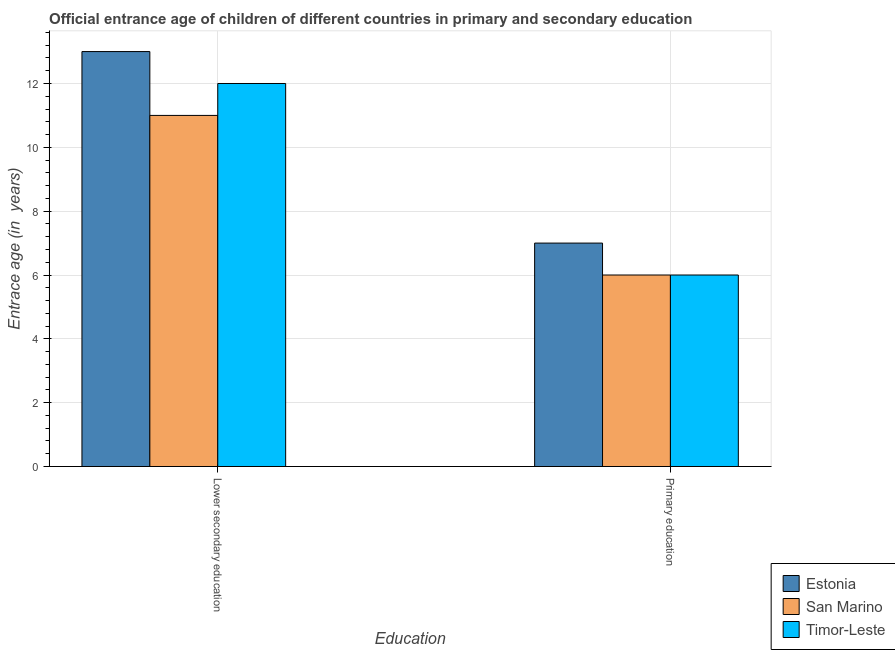How many groups of bars are there?
Make the answer very short. 2. How many bars are there on the 1st tick from the right?
Provide a short and direct response. 3. What is the label of the 2nd group of bars from the left?
Keep it short and to the point. Primary education. What is the entrance age of chiildren in primary education in Timor-Leste?
Provide a short and direct response. 6. Across all countries, what is the maximum entrance age of children in lower secondary education?
Ensure brevity in your answer.  13. Across all countries, what is the minimum entrance age of chiildren in primary education?
Your answer should be very brief. 6. In which country was the entrance age of children in lower secondary education maximum?
Your response must be concise. Estonia. In which country was the entrance age of chiildren in primary education minimum?
Give a very brief answer. San Marino. What is the total entrance age of chiildren in primary education in the graph?
Ensure brevity in your answer.  19. What is the difference between the entrance age of children in lower secondary education in Estonia and that in San Marino?
Your answer should be compact. 2. What is the difference between the entrance age of children in lower secondary education in Estonia and the entrance age of chiildren in primary education in Timor-Leste?
Offer a terse response. 7. What is the average entrance age of chiildren in primary education per country?
Your answer should be compact. 6.33. What is the difference between the entrance age of chiildren in primary education and entrance age of children in lower secondary education in Timor-Leste?
Your answer should be compact. -6. In how many countries, is the entrance age of chiildren in primary education greater than 6.8 years?
Make the answer very short. 1. What is the ratio of the entrance age of chiildren in primary education in San Marino to that in Timor-Leste?
Your answer should be very brief. 1. What does the 1st bar from the left in Lower secondary education represents?
Your response must be concise. Estonia. What does the 3rd bar from the right in Primary education represents?
Ensure brevity in your answer.  Estonia. Are all the bars in the graph horizontal?
Make the answer very short. No. Does the graph contain any zero values?
Ensure brevity in your answer.  No. Where does the legend appear in the graph?
Your answer should be compact. Bottom right. How many legend labels are there?
Make the answer very short. 3. What is the title of the graph?
Your answer should be compact. Official entrance age of children of different countries in primary and secondary education. Does "Nepal" appear as one of the legend labels in the graph?
Give a very brief answer. No. What is the label or title of the X-axis?
Provide a succinct answer. Education. What is the label or title of the Y-axis?
Give a very brief answer. Entrace age (in  years). What is the Entrace age (in  years) of San Marino in Lower secondary education?
Provide a short and direct response. 11. What is the Entrace age (in  years) of Timor-Leste in Lower secondary education?
Ensure brevity in your answer.  12. What is the Entrace age (in  years) of Estonia in Primary education?
Ensure brevity in your answer.  7. Across all Education, what is the maximum Entrace age (in  years) of Estonia?
Your answer should be very brief. 13. Across all Education, what is the maximum Entrace age (in  years) of San Marino?
Give a very brief answer. 11. Across all Education, what is the minimum Entrace age (in  years) in Estonia?
Your response must be concise. 7. Across all Education, what is the minimum Entrace age (in  years) of Timor-Leste?
Provide a short and direct response. 6. What is the total Entrace age (in  years) of Estonia in the graph?
Offer a very short reply. 20. What is the total Entrace age (in  years) of San Marino in the graph?
Keep it short and to the point. 17. What is the difference between the Entrace age (in  years) in San Marino in Lower secondary education and that in Primary education?
Give a very brief answer. 5. What is the difference between the Entrace age (in  years) in Timor-Leste in Lower secondary education and that in Primary education?
Provide a short and direct response. 6. What is the difference between the Entrace age (in  years) of Estonia in Lower secondary education and the Entrace age (in  years) of Timor-Leste in Primary education?
Your answer should be very brief. 7. What is the difference between the Entrace age (in  years) in San Marino in Lower secondary education and the Entrace age (in  years) in Timor-Leste in Primary education?
Provide a short and direct response. 5. What is the difference between the Entrace age (in  years) of Estonia and Entrace age (in  years) of Timor-Leste in Lower secondary education?
Make the answer very short. 1. What is the difference between the Entrace age (in  years) in San Marino and Entrace age (in  years) in Timor-Leste in Lower secondary education?
Give a very brief answer. -1. What is the difference between the Entrace age (in  years) of Estonia and Entrace age (in  years) of Timor-Leste in Primary education?
Your answer should be compact. 1. What is the difference between the Entrace age (in  years) in San Marino and Entrace age (in  years) in Timor-Leste in Primary education?
Your response must be concise. 0. What is the ratio of the Entrace age (in  years) in Estonia in Lower secondary education to that in Primary education?
Ensure brevity in your answer.  1.86. What is the ratio of the Entrace age (in  years) in San Marino in Lower secondary education to that in Primary education?
Your answer should be very brief. 1.83. What is the ratio of the Entrace age (in  years) in Timor-Leste in Lower secondary education to that in Primary education?
Keep it short and to the point. 2. What is the difference between the highest and the second highest Entrace age (in  years) in Estonia?
Ensure brevity in your answer.  6. What is the difference between the highest and the second highest Entrace age (in  years) in San Marino?
Make the answer very short. 5. What is the difference between the highest and the lowest Entrace age (in  years) in San Marino?
Your answer should be compact. 5. 